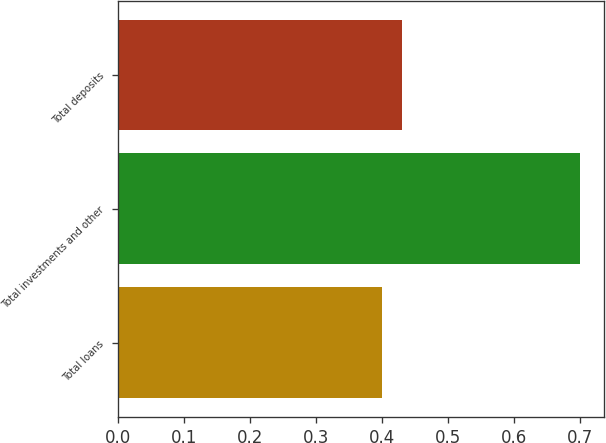<chart> <loc_0><loc_0><loc_500><loc_500><bar_chart><fcel>Total loans<fcel>Total investments and other<fcel>Total deposits<nl><fcel>0.4<fcel>0.7<fcel>0.43<nl></chart> 